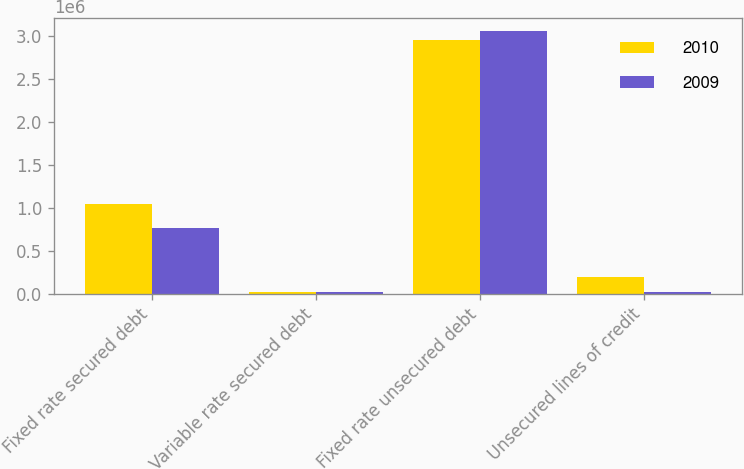<chart> <loc_0><loc_0><loc_500><loc_500><stacked_bar_chart><ecel><fcel>Fixed rate secured debt<fcel>Variable rate secured debt<fcel>Fixed rate unsecured debt<fcel>Unsecured lines of credit<nl><fcel>2010<fcel>1.04272e+06<fcel>22906<fcel>2.9484e+06<fcel>193046<nl><fcel>2009<fcel>766299<fcel>19498<fcel>3.05246e+06<fcel>15770<nl></chart> 